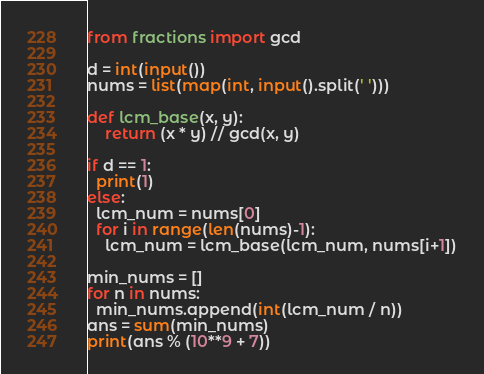<code> <loc_0><loc_0><loc_500><loc_500><_Python_>from fractions import gcd

d = int(input())
nums = list(map(int, input().split(' ')))

def lcm_base(x, y):
    return (x * y) // gcd(x, y)

if d == 1:
  print(1)
else:
  lcm_num = nums[0]
  for i in range(len(nums)-1):
    lcm_num = lcm_base(lcm_num, nums[i+1])

min_nums = []
for n in nums:
  min_nums.append(int(lcm_num / n))
ans = sum(min_nums)
print(ans % (10**9 + 7))</code> 